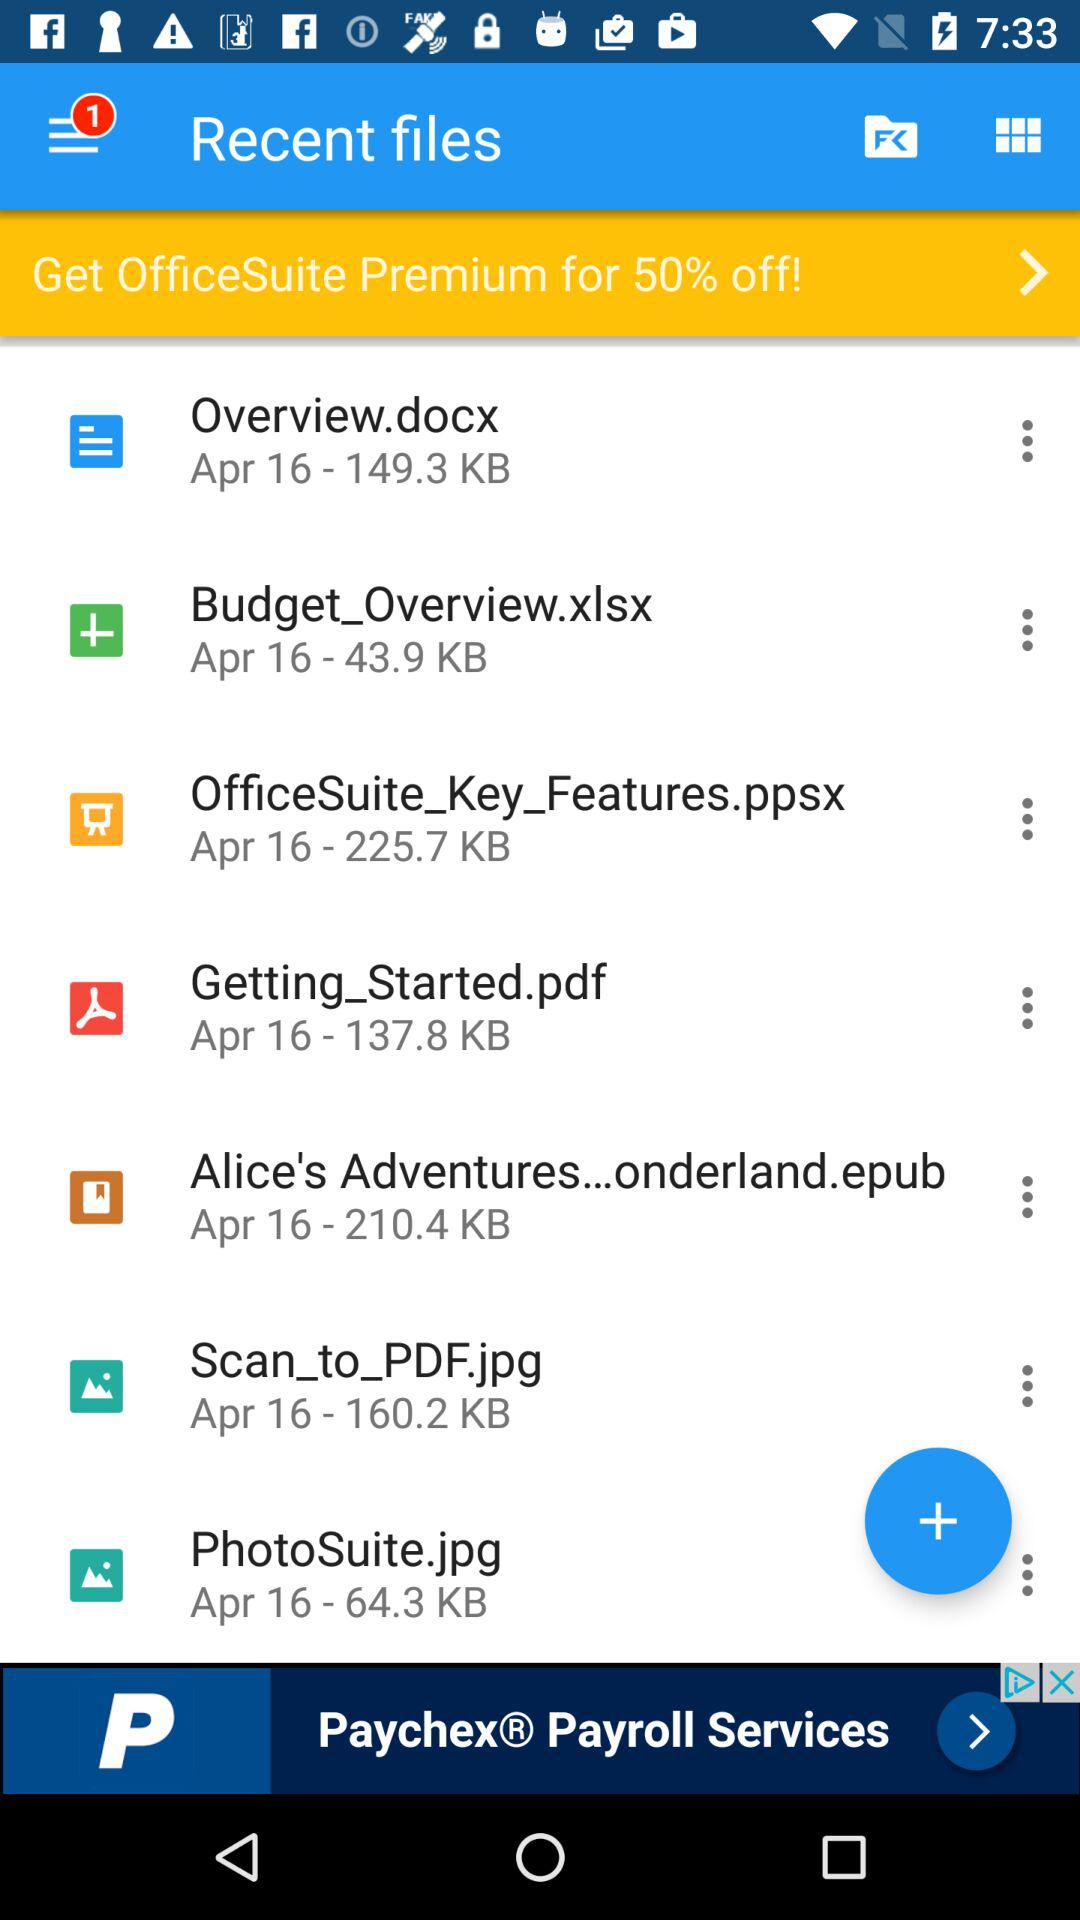How much "off" do we get on "OfficeSuite Premium"? You get 50% "off" on "OfficeSuite Premium". 